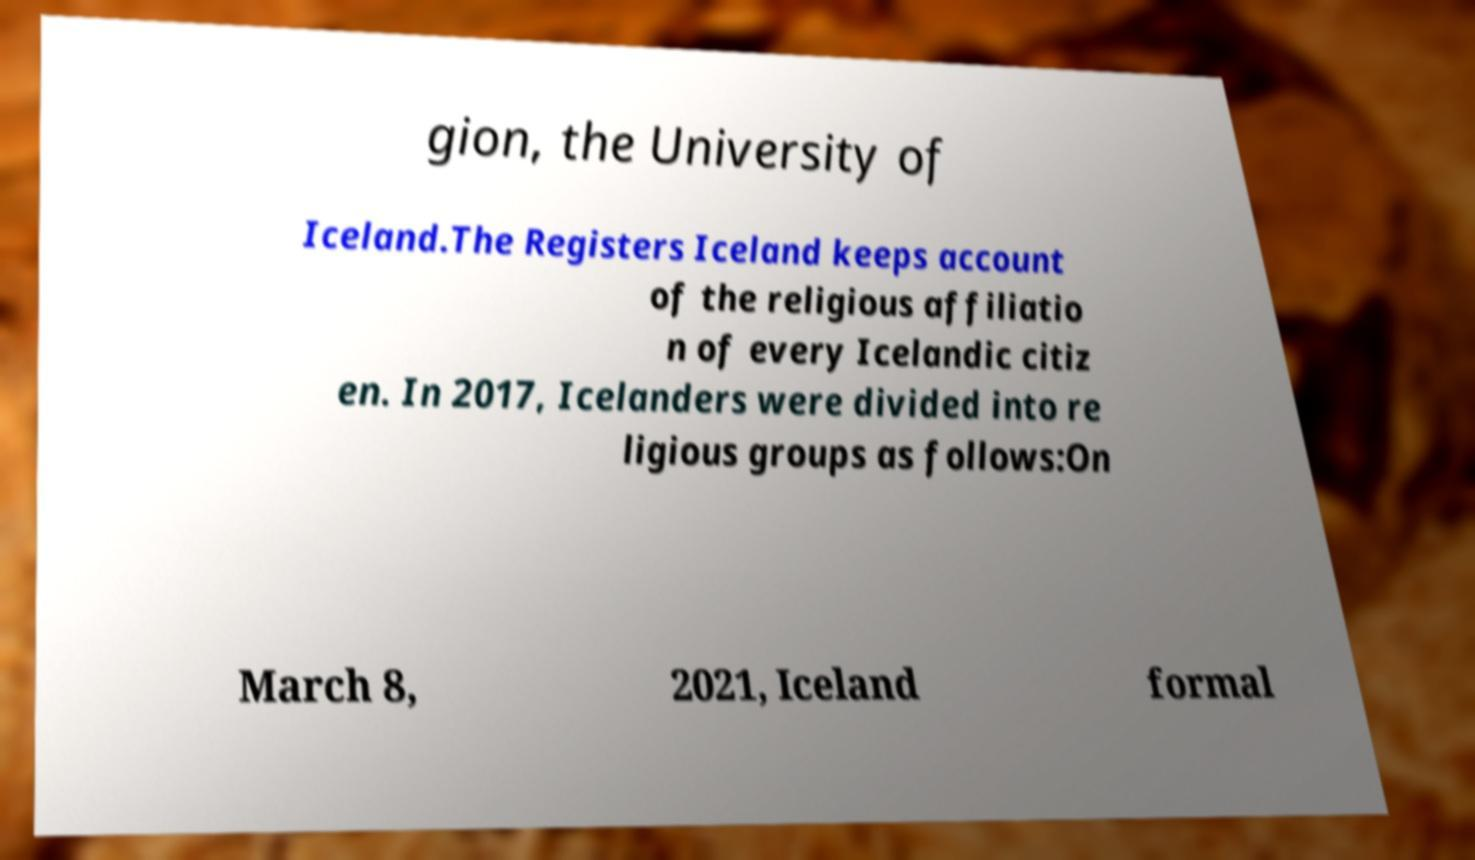There's text embedded in this image that I need extracted. Can you transcribe it verbatim? gion, the University of Iceland.The Registers Iceland keeps account of the religious affiliatio n of every Icelandic citiz en. In 2017, Icelanders were divided into re ligious groups as follows:On March 8, 2021, Iceland formal 